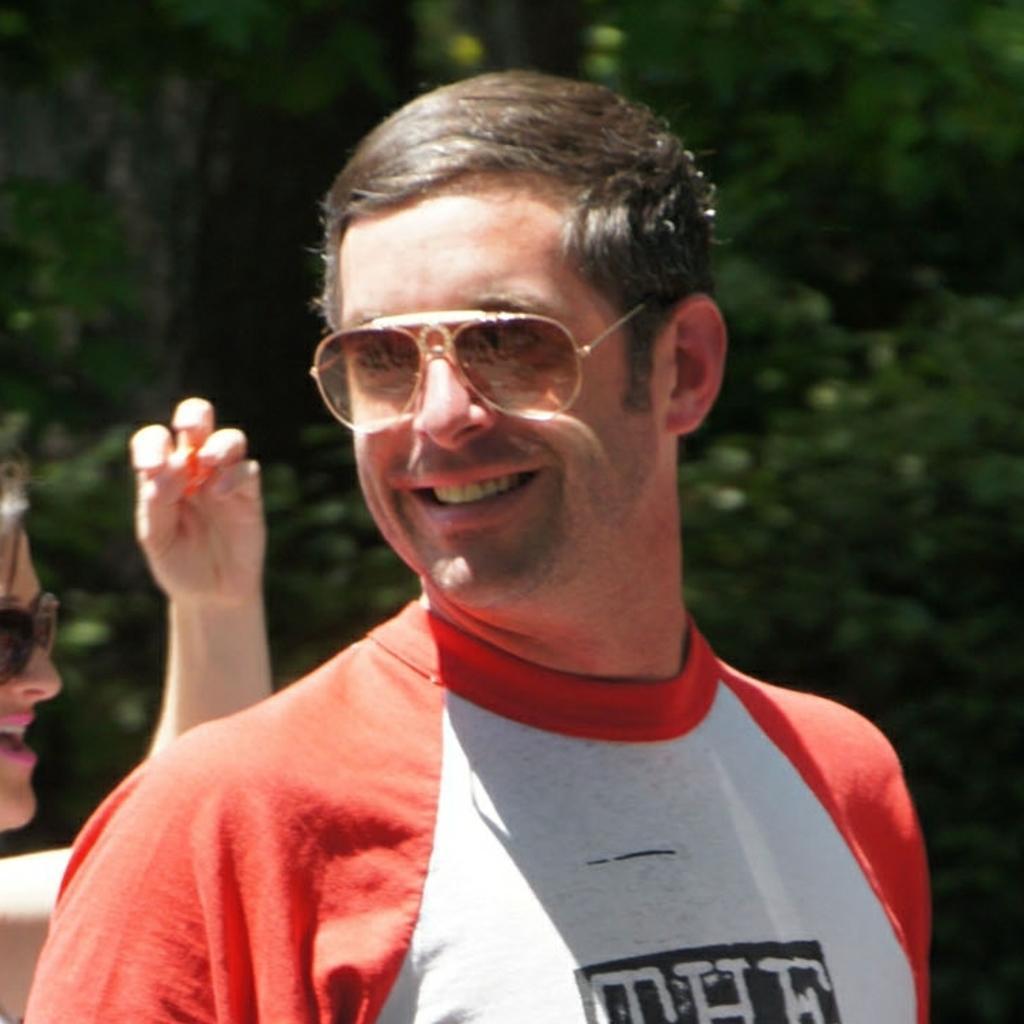Please provide a concise description of this image. In this image I can see two people. In the background, I can see the trees. 